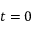<formula> <loc_0><loc_0><loc_500><loc_500>t = 0</formula> 